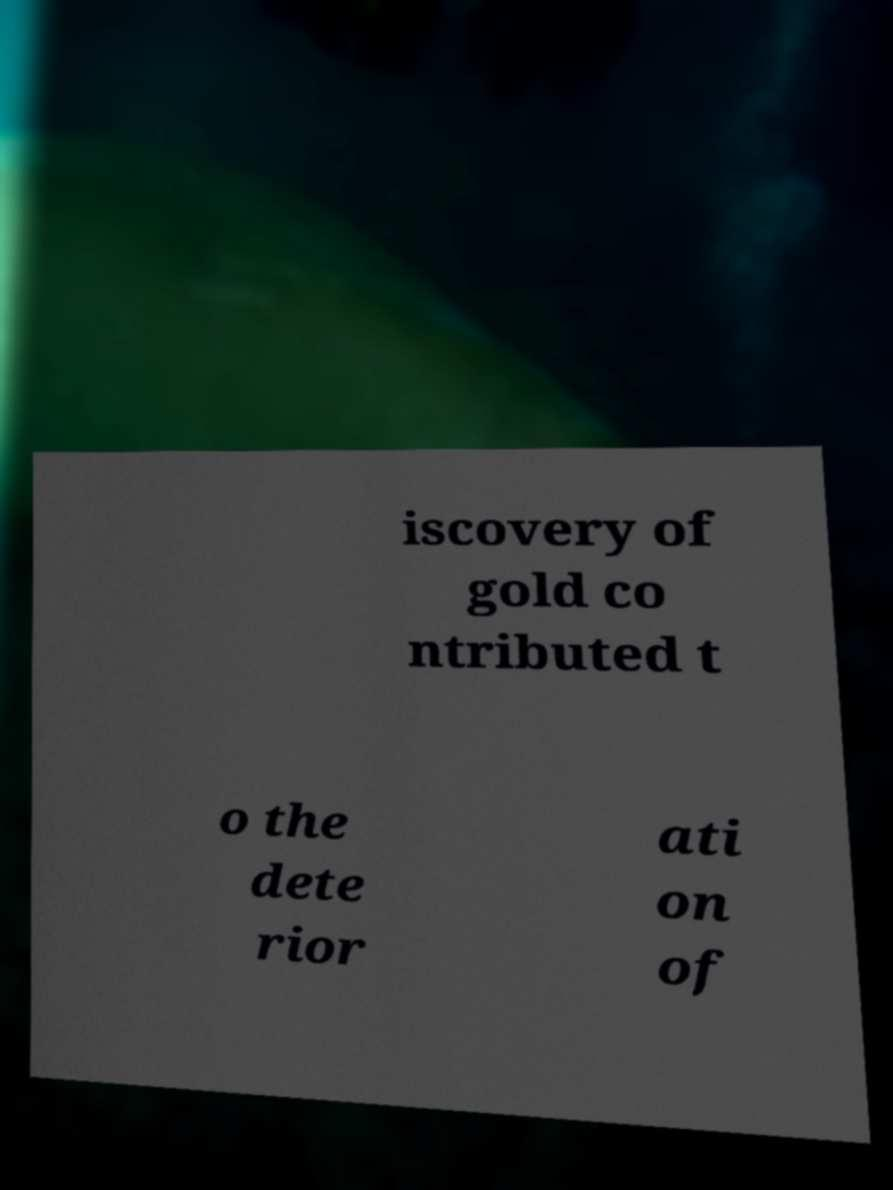Please read and relay the text visible in this image. What does it say? iscovery of gold co ntributed t o the dete rior ati on of 